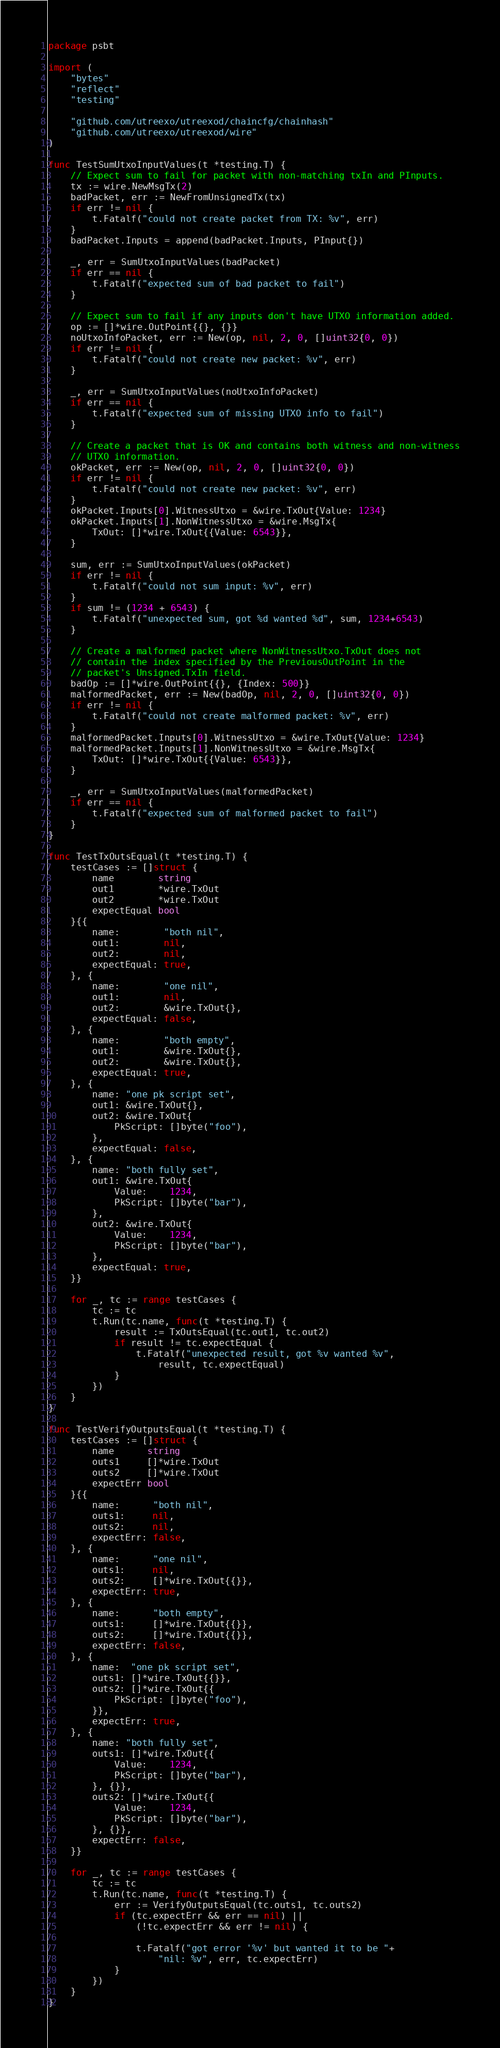<code> <loc_0><loc_0><loc_500><loc_500><_Go_>package psbt

import (
	"bytes"
	"reflect"
	"testing"

	"github.com/utreexo/utreexod/chaincfg/chainhash"
	"github.com/utreexo/utreexod/wire"
)

func TestSumUtxoInputValues(t *testing.T) {
	// Expect sum to fail for packet with non-matching txIn and PInputs.
	tx := wire.NewMsgTx(2)
	badPacket, err := NewFromUnsignedTx(tx)
	if err != nil {
		t.Fatalf("could not create packet from TX: %v", err)
	}
	badPacket.Inputs = append(badPacket.Inputs, PInput{})

	_, err = SumUtxoInputValues(badPacket)
	if err == nil {
		t.Fatalf("expected sum of bad packet to fail")
	}

	// Expect sum to fail if any inputs don't have UTXO information added.
	op := []*wire.OutPoint{{}, {}}
	noUtxoInfoPacket, err := New(op, nil, 2, 0, []uint32{0, 0})
	if err != nil {
		t.Fatalf("could not create new packet: %v", err)
	}

	_, err = SumUtxoInputValues(noUtxoInfoPacket)
	if err == nil {
		t.Fatalf("expected sum of missing UTXO info to fail")
	}

	// Create a packet that is OK and contains both witness and non-witness
	// UTXO information.
	okPacket, err := New(op, nil, 2, 0, []uint32{0, 0})
	if err != nil {
		t.Fatalf("could not create new packet: %v", err)
	}
	okPacket.Inputs[0].WitnessUtxo = &wire.TxOut{Value: 1234}
	okPacket.Inputs[1].NonWitnessUtxo = &wire.MsgTx{
		TxOut: []*wire.TxOut{{Value: 6543}},
	}

	sum, err := SumUtxoInputValues(okPacket)
	if err != nil {
		t.Fatalf("could not sum input: %v", err)
	}
	if sum != (1234 + 6543) {
		t.Fatalf("unexpected sum, got %d wanted %d", sum, 1234+6543)
	}

	// Create a malformed packet where NonWitnessUtxo.TxOut does not
	// contain the index specified by the PreviousOutPoint in the
	// packet's Unsigned.TxIn field.
	badOp := []*wire.OutPoint{{}, {Index: 500}}
	malformedPacket, err := New(badOp, nil, 2, 0, []uint32{0, 0})
	if err != nil {
		t.Fatalf("could not create malformed packet: %v", err)
	}
	malformedPacket.Inputs[0].WitnessUtxo = &wire.TxOut{Value: 1234}
	malformedPacket.Inputs[1].NonWitnessUtxo = &wire.MsgTx{
		TxOut: []*wire.TxOut{{Value: 6543}},
	}

	_, err = SumUtxoInputValues(malformedPacket)
	if err == nil {
		t.Fatalf("expected sum of malformed packet to fail")
	}
}

func TestTxOutsEqual(t *testing.T) {
	testCases := []struct {
		name        string
		out1        *wire.TxOut
		out2        *wire.TxOut
		expectEqual bool
	}{{
		name:        "both nil",
		out1:        nil,
		out2:        nil,
		expectEqual: true,
	}, {
		name:        "one nil",
		out1:        nil,
		out2:        &wire.TxOut{},
		expectEqual: false,
	}, {
		name:        "both empty",
		out1:        &wire.TxOut{},
		out2:        &wire.TxOut{},
		expectEqual: true,
	}, {
		name: "one pk script set",
		out1: &wire.TxOut{},
		out2: &wire.TxOut{
			PkScript: []byte("foo"),
		},
		expectEqual: false,
	}, {
		name: "both fully set",
		out1: &wire.TxOut{
			Value:    1234,
			PkScript: []byte("bar"),
		},
		out2: &wire.TxOut{
			Value:    1234,
			PkScript: []byte("bar"),
		},
		expectEqual: true,
	}}

	for _, tc := range testCases {
		tc := tc
		t.Run(tc.name, func(t *testing.T) {
			result := TxOutsEqual(tc.out1, tc.out2)
			if result != tc.expectEqual {
				t.Fatalf("unexpected result, got %v wanted %v",
					result, tc.expectEqual)
			}
		})
	}
}

func TestVerifyOutputsEqual(t *testing.T) {
	testCases := []struct {
		name      string
		outs1     []*wire.TxOut
		outs2     []*wire.TxOut
		expectErr bool
	}{{
		name:      "both nil",
		outs1:     nil,
		outs2:     nil,
		expectErr: false,
	}, {
		name:      "one nil",
		outs1:     nil,
		outs2:     []*wire.TxOut{{}},
		expectErr: true,
	}, {
		name:      "both empty",
		outs1:     []*wire.TxOut{{}},
		outs2:     []*wire.TxOut{{}},
		expectErr: false,
	}, {
		name:  "one pk script set",
		outs1: []*wire.TxOut{{}},
		outs2: []*wire.TxOut{{
			PkScript: []byte("foo"),
		}},
		expectErr: true,
	}, {
		name: "both fully set",
		outs1: []*wire.TxOut{{
			Value:    1234,
			PkScript: []byte("bar"),
		}, {}},
		outs2: []*wire.TxOut{{
			Value:    1234,
			PkScript: []byte("bar"),
		}, {}},
		expectErr: false,
	}}

	for _, tc := range testCases {
		tc := tc
		t.Run(tc.name, func(t *testing.T) {
			err := VerifyOutputsEqual(tc.outs1, tc.outs2)
			if (tc.expectErr && err == nil) ||
				(!tc.expectErr && err != nil) {

				t.Fatalf("got error '%v' but wanted it to be "+
					"nil: %v", err, tc.expectErr)
			}
		})
	}
}
</code> 